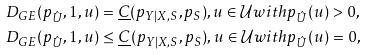<formula> <loc_0><loc_0><loc_500><loc_500>& D _ { G E } ( p _ { \hat { U } } , 1 , u ) = \underline { C } ( p _ { Y | X , S } , p _ { S } ) , u \in \mathcal { U } w i t h p _ { \hat { U } } ( u ) > 0 , \\ & D _ { G E } ( p _ { \hat { U } } , 1 , u ) \leq \underline { C } ( p _ { Y | X , S } , p _ { S } ) , u \in \mathcal { U } w i t h p _ { \hat { U } } ( u ) = 0 ,</formula> 